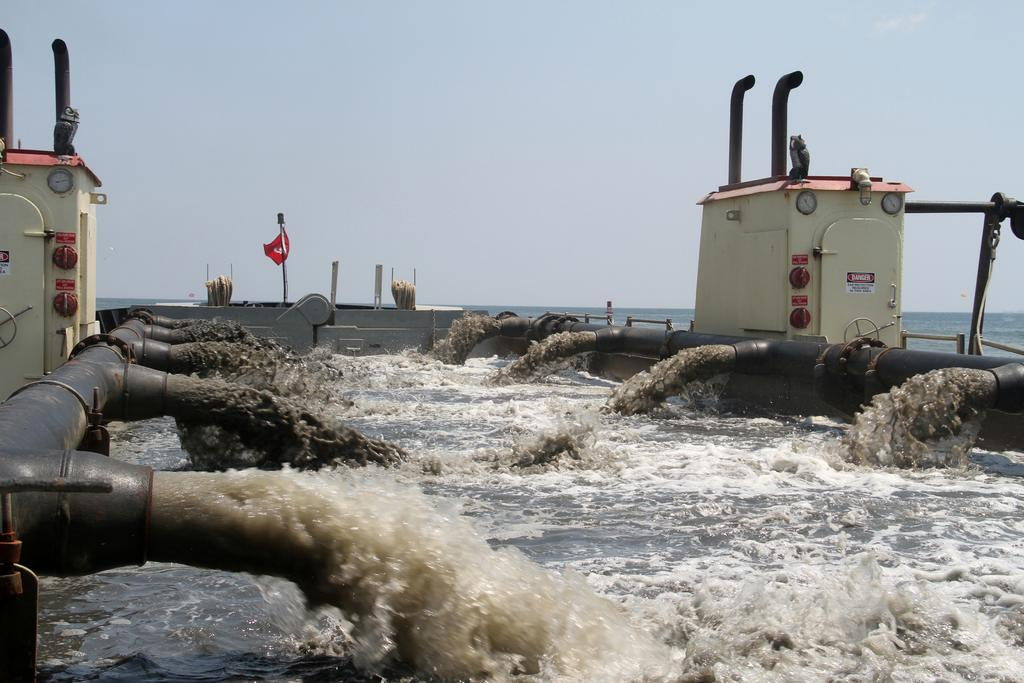What is the primary element visible in the image? There is water in the image. What infrastructure is related to the water in the image? Water pipe lines are visible in the image. What type of building can be seen in the image? There is an electric house in the image. What symbol is present in the image? There is a flag in the image. What can be seen in the background of the image? The sky is visible in the background of the image. What type of cushion is being used to support the water in the image? There is no cushion present in the image; the water is not supported by a cushion. 